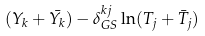<formula> <loc_0><loc_0><loc_500><loc_500>( Y _ { k } + \bar { Y _ { k } } ) - \delta _ { G S } ^ { k j } \ln ( T _ { j } + \bar { T } _ { j } )</formula> 